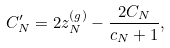Convert formula to latex. <formula><loc_0><loc_0><loc_500><loc_500>C ^ { \prime } _ { N } = 2 z _ { N } ^ { ( g ) } - \frac { 2 C _ { N } } { c _ { N } + 1 } ,</formula> 